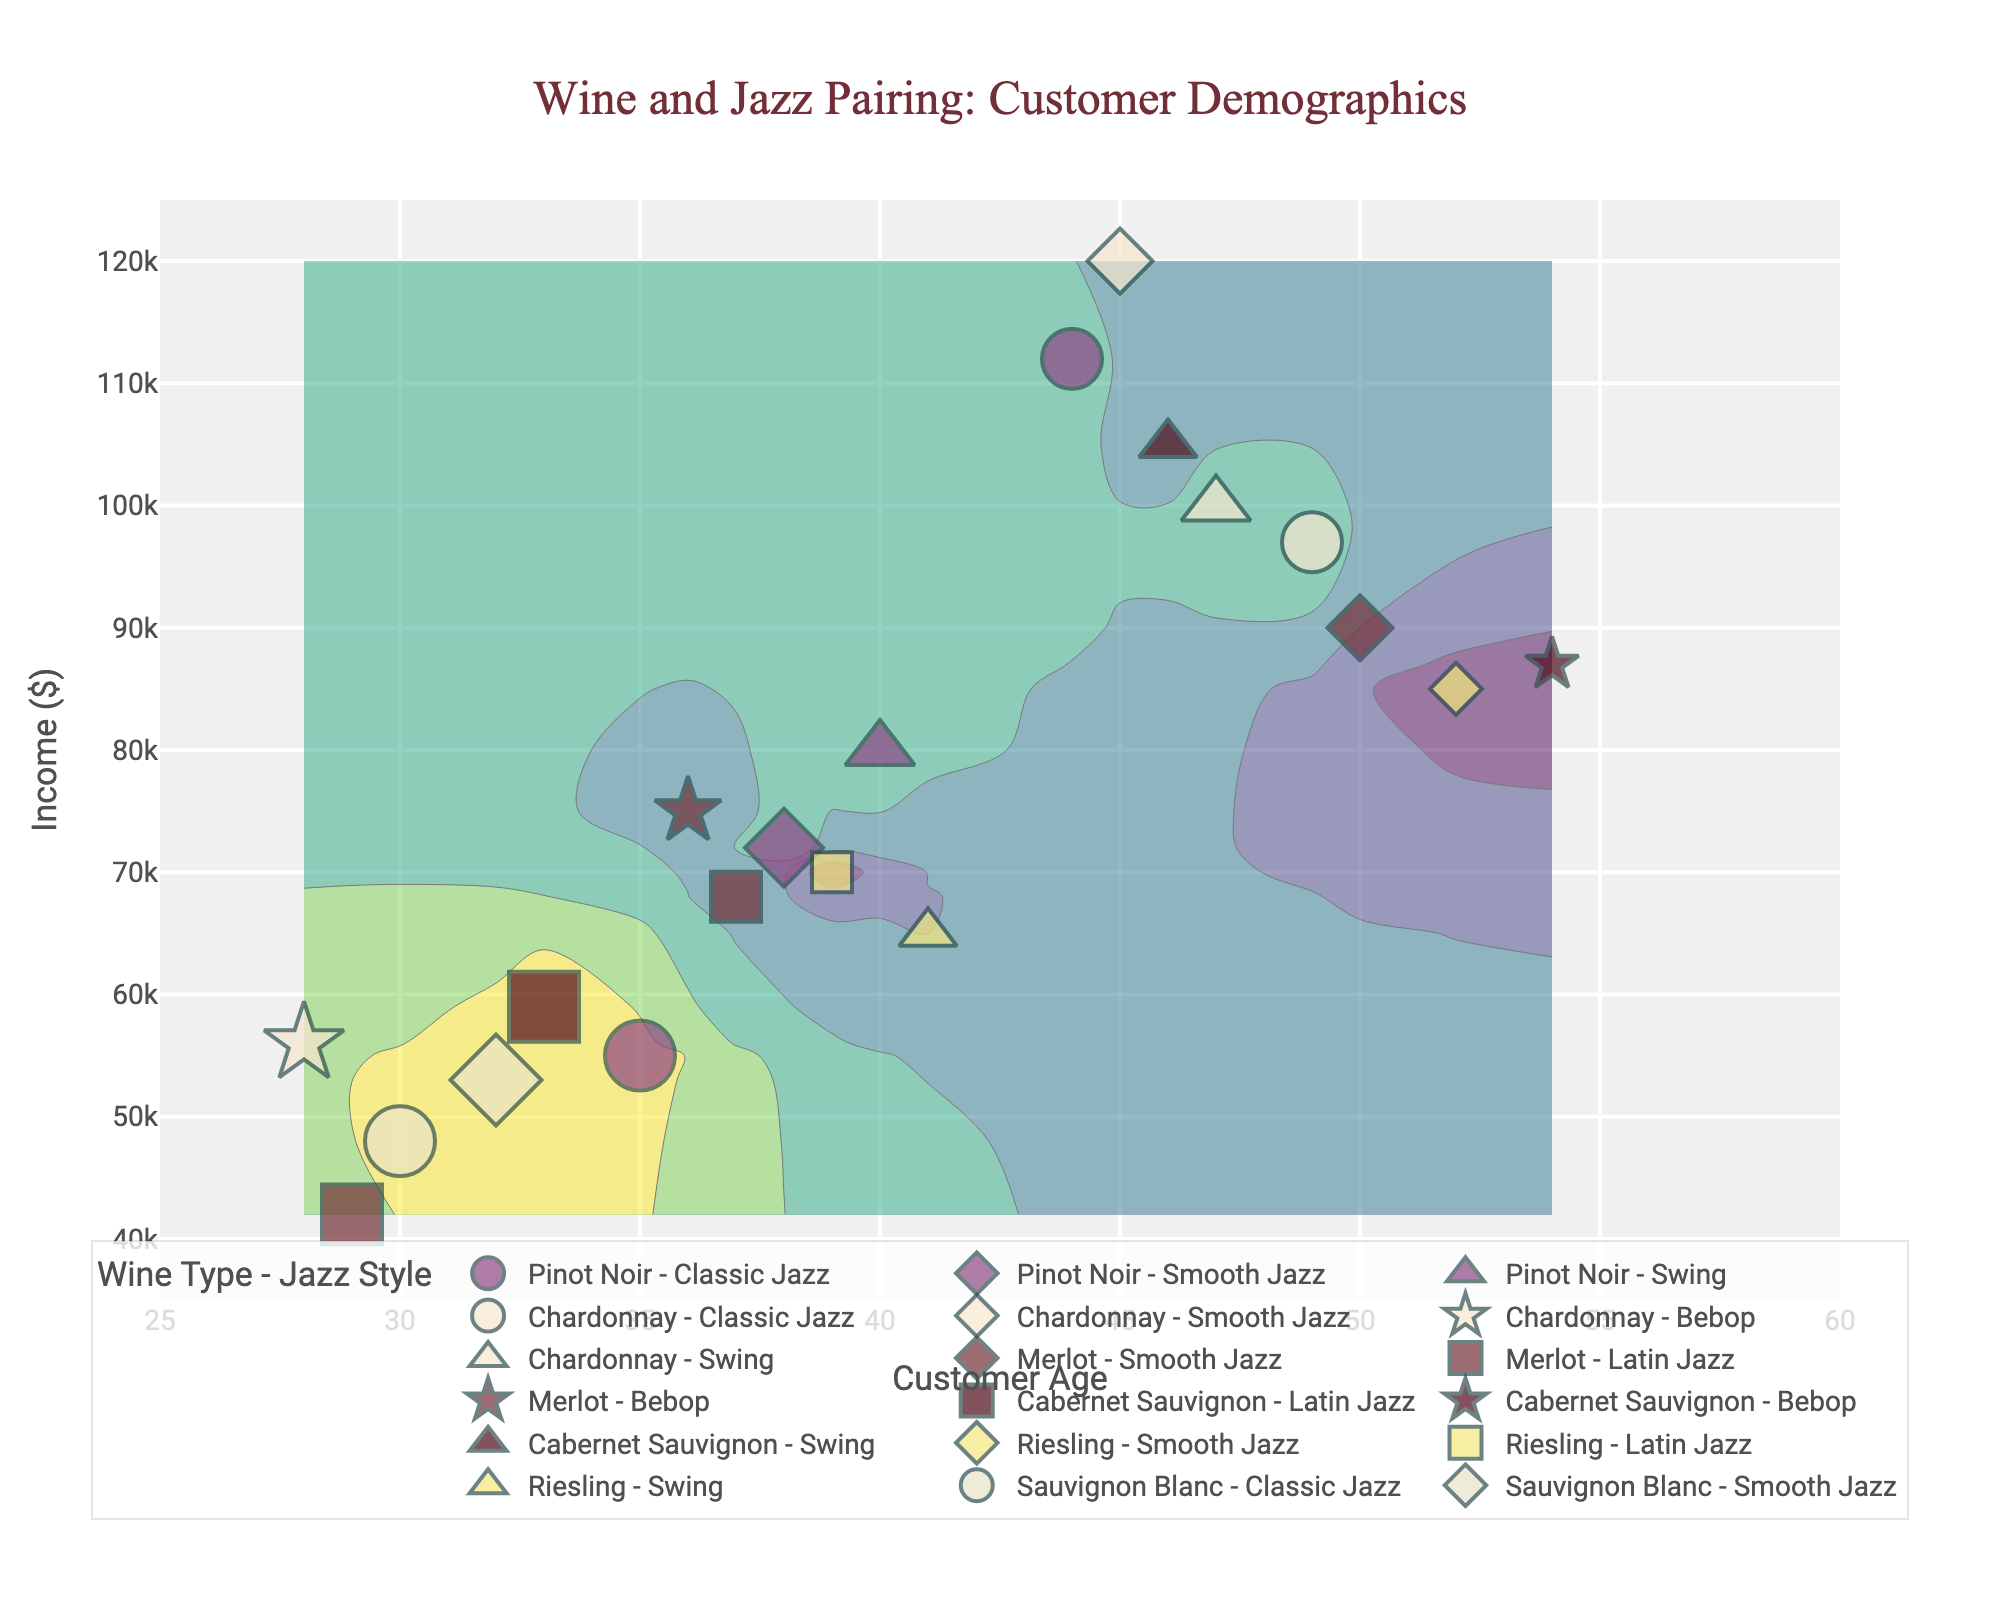What is the title of the figure? The title is located at the top of the figure and typically provides an overall description of what the figure is about. Here, it reads "Wine and Jazz Pairing: Customer Demographics".
Answer: Wine and Jazz Pairing: Customer Demographics What are the units for the y-axis? The y-axis in the figure displays the income levels of customers, as indicated by the label "Income ($)". Therefore, the units are in dollars.
Answer: Dollars Which wine type is associated with the highest purchase volume for Classic Jazz lovers? To answer this question, identify the markers representing Classic Jazz (circles) and then locate the one with the largest size. The figure shows a circle in Pinot Noir with a large size, indicating it has the highest purchase volume for Classic Jazz lovers.
Answer: Pinot Noir How many different wine types are represented in the figure? By counting the unique wine types displayed in the legend, we can see there are six different wine types: Pinot Noir, Chardonnay, Merlot, Cabernet Sauvignon, Riesling, and Sauvignon Blanc.
Answer: Six Comparing Cabernet Sauvignon and Merlot, which wine type has more smooth jazz lovers? To answer this, compare the number of markers for Smooth Jazz (diamonds) for both wine types. Cabernet Sauvignon has no markers with this symbol, while Merlot has markers, indicating Merlot has more Smooth Jazz lovers.
Answer: Merlot What is the age range of customers who purchased Sauvignon Blanc paired with Classic Jazz? Locate markers for Sauvignon Blanc (colored as indicated in the legend) with the Classic Jazz (circle) symbol. These markers are around age 30.
Answer: 30-32 Which wine type relates to the highest income customers? By examining the markers positioned at the higher end of the y-axis, which represents income, the Pinot Noir and Chardonnay wine types appear frequently. Checking against the highest positions, Pinot Noir at age 45 and income 120,000 stands out.
Answer: Pinot Noir What is the general trend in purchase volume as the age of customers increases for Riesling and Swing Jazz? Observe the markers for Riesling and Swing Jazz (triangle-up); they remain moderately sized and do not vary widely as age increases, indicating a generally steady purchase volume across ages.
Answer: Steady Which jazz style has customers with the broadest income range for Chardonnay? For Chardonnay, identify all symbol types (representing jazz styles) and evaluate their vertical spread on the y-axis (income levels). It appears Smooth Jazz (diamond) covers a broad range from 85,000 to 112,000 in income.
Answer: Smooth Jazz How many different symbols are used to represent jazz styles? Count the number of unique symbols provided for the jazz styles: circle, diamond, square, star, and triangle-up. There are five different symbols.
Answer: Five 